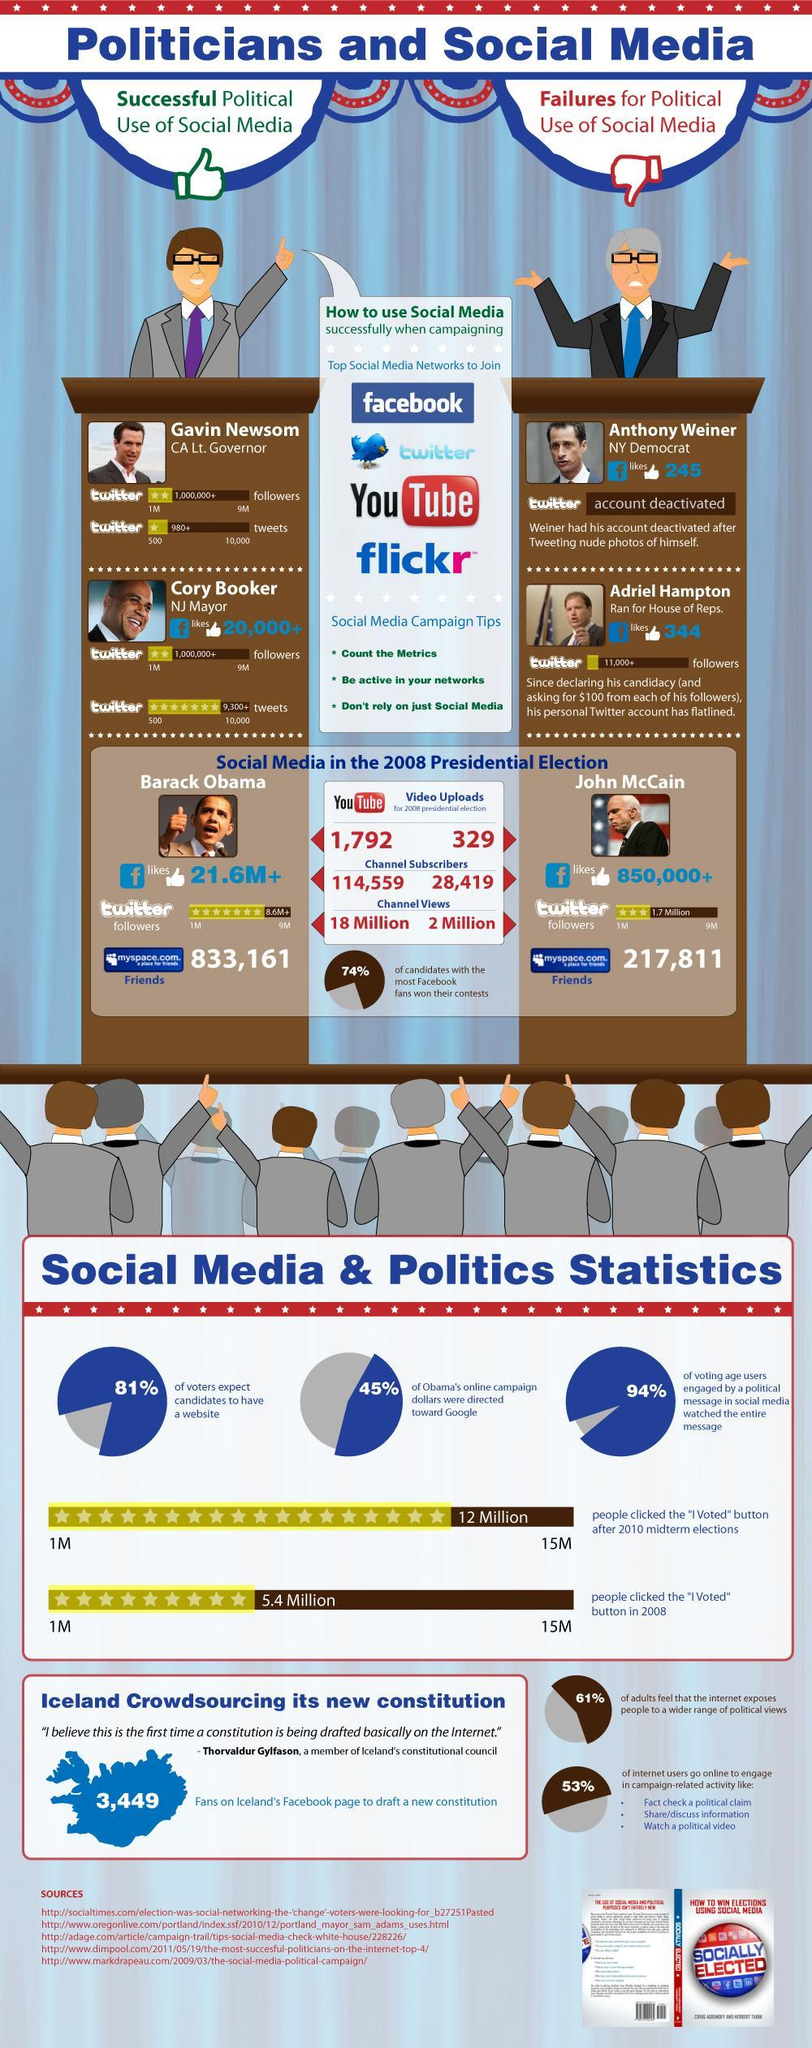Whose details do not have any Facebook likes
Answer the question with a short phrase. Gavin Newsom Which are the top socail media networks to join facebook, twitter, youtube, flickr what % of adults do not feel that the internet exposes people to a wider range of political views 39 Who have had successful political use  of social media Gavin Newsom, Cory Booker What % of voters do not expect candidates to have a website 19 Who were the failures for political use of social media Anthony Weiner, Adriel Hampton Who asked $100 from each of his follower Adriel Hampton what are the social media campaign tips count the metrics, be active in your networks, don't reply on just social media How many twitter followers does Barack Obama have 8.6M+ 